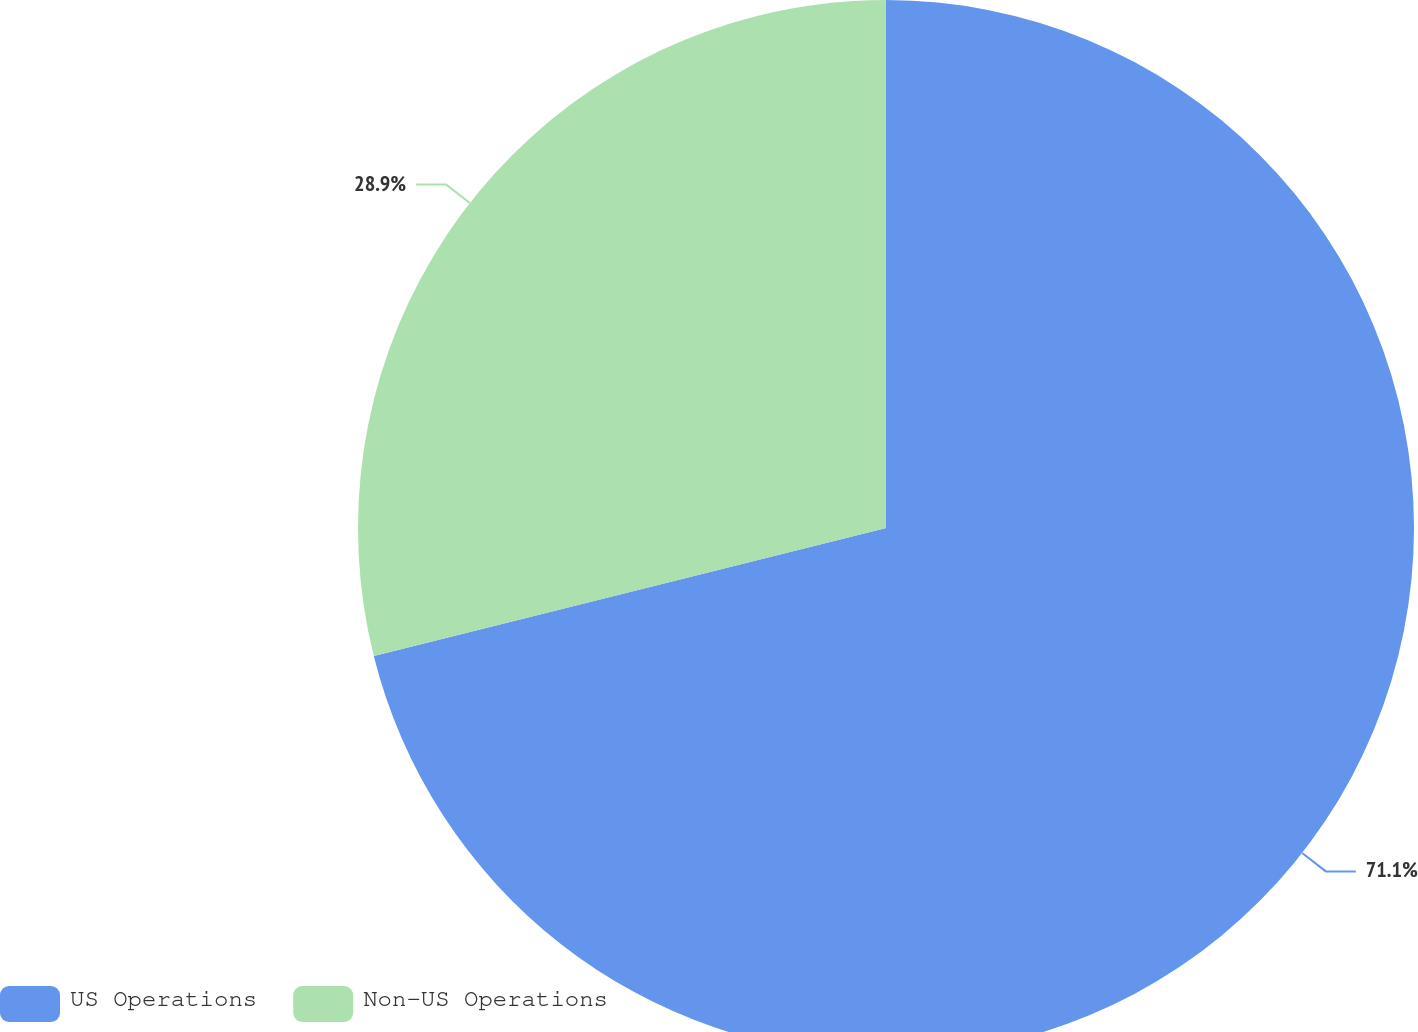Convert chart to OTSL. <chart><loc_0><loc_0><loc_500><loc_500><pie_chart><fcel>US Operations<fcel>Non-US Operations<nl><fcel>71.1%<fcel>28.9%<nl></chart> 